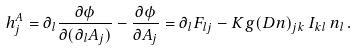<formula> <loc_0><loc_0><loc_500><loc_500>h ^ { A } _ { j } = \partial _ { l } \frac { \partial \phi } { \partial ( \partial _ { l } A _ { j } ) } - \frac { \partial \phi } { \partial A _ { j } } = \partial _ { l } F _ { l j } - K g ( D n ) _ { j k } \, I _ { k l } \, n _ { l } \, .</formula> 